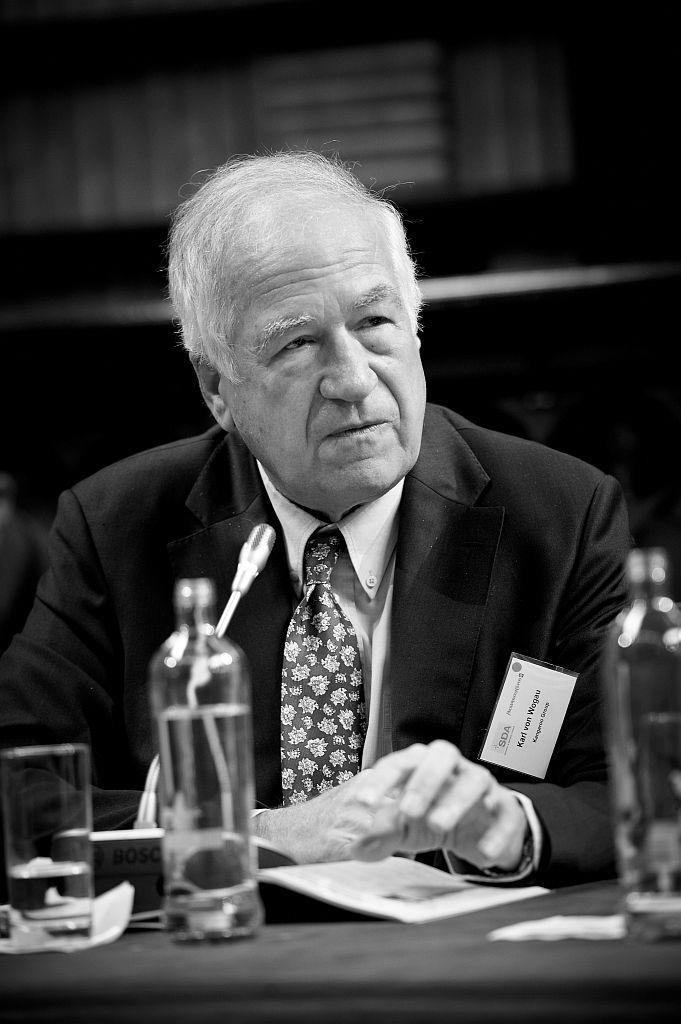What is the man in the image doing? The man is sitting in the image. What is in front of the man? The man has a table in front of him. What items can be seen on the table? There is a water bottle, a water glass, and a book on the table. What type of tiger can be seen in the scene in the image? There is no tiger present in the image; it only features a man sitting at a table with various items. 